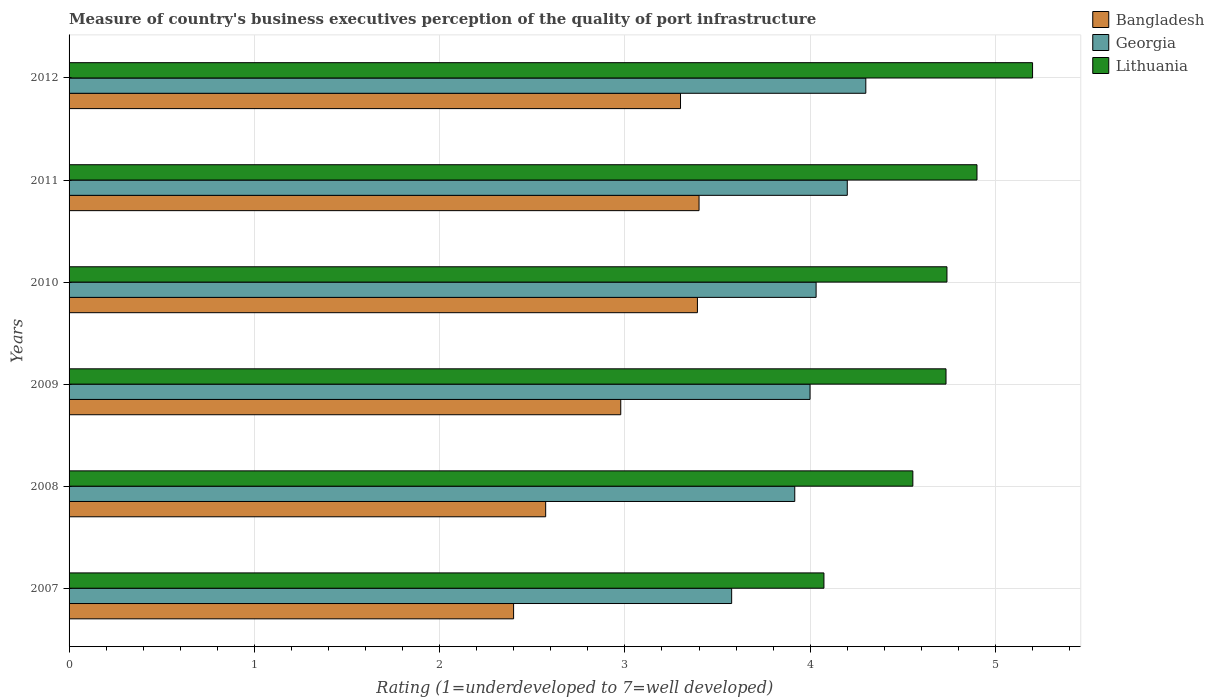How many different coloured bars are there?
Ensure brevity in your answer.  3. How many groups of bars are there?
Provide a succinct answer. 6. Are the number of bars per tick equal to the number of legend labels?
Provide a succinct answer. Yes. What is the label of the 1st group of bars from the top?
Offer a very short reply. 2012. In how many cases, is the number of bars for a given year not equal to the number of legend labels?
Offer a very short reply. 0. What is the ratings of the quality of port infrastructure in Lithuania in 2008?
Ensure brevity in your answer.  4.55. Across all years, what is the maximum ratings of the quality of port infrastructure in Lithuania?
Offer a terse response. 5.2. Across all years, what is the minimum ratings of the quality of port infrastructure in Lithuania?
Make the answer very short. 4.07. In which year was the ratings of the quality of port infrastructure in Georgia minimum?
Make the answer very short. 2007. What is the total ratings of the quality of port infrastructure in Bangladesh in the graph?
Offer a very short reply. 18.04. What is the difference between the ratings of the quality of port infrastructure in Georgia in 2008 and that in 2011?
Make the answer very short. -0.28. What is the difference between the ratings of the quality of port infrastructure in Bangladesh in 2007 and the ratings of the quality of port infrastructure in Georgia in 2012?
Your answer should be compact. -1.9. What is the average ratings of the quality of port infrastructure in Georgia per year?
Make the answer very short. 4. In the year 2008, what is the difference between the ratings of the quality of port infrastructure in Bangladesh and ratings of the quality of port infrastructure in Lithuania?
Ensure brevity in your answer.  -1.98. What is the ratio of the ratings of the quality of port infrastructure in Bangladesh in 2009 to that in 2012?
Ensure brevity in your answer.  0.9. Is the ratings of the quality of port infrastructure in Georgia in 2007 less than that in 2008?
Your response must be concise. Yes. What is the difference between the highest and the second highest ratings of the quality of port infrastructure in Georgia?
Give a very brief answer. 0.1. What is the difference between the highest and the lowest ratings of the quality of port infrastructure in Lithuania?
Ensure brevity in your answer.  1.13. Is the sum of the ratings of the quality of port infrastructure in Bangladesh in 2008 and 2011 greater than the maximum ratings of the quality of port infrastructure in Lithuania across all years?
Offer a very short reply. Yes. What does the 2nd bar from the top in 2009 represents?
Ensure brevity in your answer.  Georgia. What does the 3rd bar from the bottom in 2012 represents?
Ensure brevity in your answer.  Lithuania. How many bars are there?
Provide a short and direct response. 18. Are all the bars in the graph horizontal?
Your answer should be very brief. Yes. Are the values on the major ticks of X-axis written in scientific E-notation?
Your answer should be compact. No. Does the graph contain grids?
Ensure brevity in your answer.  Yes. Where does the legend appear in the graph?
Provide a short and direct response. Top right. How are the legend labels stacked?
Your answer should be very brief. Vertical. What is the title of the graph?
Your response must be concise. Measure of country's business executives perception of the quality of port infrastructure. What is the label or title of the X-axis?
Offer a very short reply. Rating (1=underdeveloped to 7=well developed). What is the Rating (1=underdeveloped to 7=well developed) of Bangladesh in 2007?
Offer a very short reply. 2.4. What is the Rating (1=underdeveloped to 7=well developed) in Georgia in 2007?
Provide a short and direct response. 3.58. What is the Rating (1=underdeveloped to 7=well developed) of Lithuania in 2007?
Your answer should be compact. 4.07. What is the Rating (1=underdeveloped to 7=well developed) of Bangladesh in 2008?
Provide a succinct answer. 2.57. What is the Rating (1=underdeveloped to 7=well developed) of Georgia in 2008?
Keep it short and to the point. 3.92. What is the Rating (1=underdeveloped to 7=well developed) of Lithuania in 2008?
Provide a short and direct response. 4.55. What is the Rating (1=underdeveloped to 7=well developed) of Bangladesh in 2009?
Keep it short and to the point. 2.98. What is the Rating (1=underdeveloped to 7=well developed) in Georgia in 2009?
Give a very brief answer. 4. What is the Rating (1=underdeveloped to 7=well developed) of Lithuania in 2009?
Ensure brevity in your answer.  4.73. What is the Rating (1=underdeveloped to 7=well developed) of Bangladesh in 2010?
Give a very brief answer. 3.39. What is the Rating (1=underdeveloped to 7=well developed) in Georgia in 2010?
Ensure brevity in your answer.  4.03. What is the Rating (1=underdeveloped to 7=well developed) of Lithuania in 2010?
Keep it short and to the point. 4.74. What is the Rating (1=underdeveloped to 7=well developed) in Georgia in 2012?
Offer a terse response. 4.3. What is the Rating (1=underdeveloped to 7=well developed) of Lithuania in 2012?
Your answer should be compact. 5.2. Across all years, what is the maximum Rating (1=underdeveloped to 7=well developed) of Bangladesh?
Offer a very short reply. 3.4. Across all years, what is the minimum Rating (1=underdeveloped to 7=well developed) in Bangladesh?
Give a very brief answer. 2.4. Across all years, what is the minimum Rating (1=underdeveloped to 7=well developed) in Georgia?
Keep it short and to the point. 3.58. Across all years, what is the minimum Rating (1=underdeveloped to 7=well developed) of Lithuania?
Your response must be concise. 4.07. What is the total Rating (1=underdeveloped to 7=well developed) in Bangladesh in the graph?
Offer a terse response. 18.04. What is the total Rating (1=underdeveloped to 7=well developed) of Georgia in the graph?
Ensure brevity in your answer.  24.02. What is the total Rating (1=underdeveloped to 7=well developed) in Lithuania in the graph?
Your answer should be very brief. 28.2. What is the difference between the Rating (1=underdeveloped to 7=well developed) in Bangladesh in 2007 and that in 2008?
Make the answer very short. -0.17. What is the difference between the Rating (1=underdeveloped to 7=well developed) of Georgia in 2007 and that in 2008?
Make the answer very short. -0.34. What is the difference between the Rating (1=underdeveloped to 7=well developed) of Lithuania in 2007 and that in 2008?
Your answer should be very brief. -0.48. What is the difference between the Rating (1=underdeveloped to 7=well developed) of Bangladesh in 2007 and that in 2009?
Provide a succinct answer. -0.58. What is the difference between the Rating (1=underdeveloped to 7=well developed) of Georgia in 2007 and that in 2009?
Provide a succinct answer. -0.42. What is the difference between the Rating (1=underdeveloped to 7=well developed) of Lithuania in 2007 and that in 2009?
Provide a succinct answer. -0.66. What is the difference between the Rating (1=underdeveloped to 7=well developed) in Bangladesh in 2007 and that in 2010?
Provide a succinct answer. -0.99. What is the difference between the Rating (1=underdeveloped to 7=well developed) in Georgia in 2007 and that in 2010?
Your answer should be very brief. -0.46. What is the difference between the Rating (1=underdeveloped to 7=well developed) in Lithuania in 2007 and that in 2010?
Provide a short and direct response. -0.66. What is the difference between the Rating (1=underdeveloped to 7=well developed) of Bangladesh in 2007 and that in 2011?
Provide a short and direct response. -1. What is the difference between the Rating (1=underdeveloped to 7=well developed) in Georgia in 2007 and that in 2011?
Your answer should be very brief. -0.62. What is the difference between the Rating (1=underdeveloped to 7=well developed) in Lithuania in 2007 and that in 2011?
Your answer should be compact. -0.83. What is the difference between the Rating (1=underdeveloped to 7=well developed) in Bangladesh in 2007 and that in 2012?
Your answer should be compact. -0.9. What is the difference between the Rating (1=underdeveloped to 7=well developed) in Georgia in 2007 and that in 2012?
Your answer should be compact. -0.72. What is the difference between the Rating (1=underdeveloped to 7=well developed) of Lithuania in 2007 and that in 2012?
Provide a short and direct response. -1.13. What is the difference between the Rating (1=underdeveloped to 7=well developed) in Bangladesh in 2008 and that in 2009?
Your response must be concise. -0.41. What is the difference between the Rating (1=underdeveloped to 7=well developed) of Georgia in 2008 and that in 2009?
Your response must be concise. -0.08. What is the difference between the Rating (1=underdeveloped to 7=well developed) of Lithuania in 2008 and that in 2009?
Make the answer very short. -0.18. What is the difference between the Rating (1=underdeveloped to 7=well developed) of Bangladesh in 2008 and that in 2010?
Provide a short and direct response. -0.82. What is the difference between the Rating (1=underdeveloped to 7=well developed) in Georgia in 2008 and that in 2010?
Offer a very short reply. -0.12. What is the difference between the Rating (1=underdeveloped to 7=well developed) in Lithuania in 2008 and that in 2010?
Your response must be concise. -0.18. What is the difference between the Rating (1=underdeveloped to 7=well developed) in Bangladesh in 2008 and that in 2011?
Keep it short and to the point. -0.83. What is the difference between the Rating (1=underdeveloped to 7=well developed) of Georgia in 2008 and that in 2011?
Your response must be concise. -0.28. What is the difference between the Rating (1=underdeveloped to 7=well developed) in Lithuania in 2008 and that in 2011?
Give a very brief answer. -0.35. What is the difference between the Rating (1=underdeveloped to 7=well developed) in Bangladesh in 2008 and that in 2012?
Ensure brevity in your answer.  -0.73. What is the difference between the Rating (1=underdeveloped to 7=well developed) in Georgia in 2008 and that in 2012?
Offer a terse response. -0.38. What is the difference between the Rating (1=underdeveloped to 7=well developed) of Lithuania in 2008 and that in 2012?
Offer a terse response. -0.65. What is the difference between the Rating (1=underdeveloped to 7=well developed) of Bangladesh in 2009 and that in 2010?
Provide a short and direct response. -0.41. What is the difference between the Rating (1=underdeveloped to 7=well developed) in Georgia in 2009 and that in 2010?
Your response must be concise. -0.03. What is the difference between the Rating (1=underdeveloped to 7=well developed) of Lithuania in 2009 and that in 2010?
Provide a succinct answer. -0.01. What is the difference between the Rating (1=underdeveloped to 7=well developed) in Bangladesh in 2009 and that in 2011?
Offer a terse response. -0.42. What is the difference between the Rating (1=underdeveloped to 7=well developed) of Georgia in 2009 and that in 2011?
Make the answer very short. -0.2. What is the difference between the Rating (1=underdeveloped to 7=well developed) of Lithuania in 2009 and that in 2011?
Your answer should be very brief. -0.17. What is the difference between the Rating (1=underdeveloped to 7=well developed) of Bangladesh in 2009 and that in 2012?
Your answer should be compact. -0.32. What is the difference between the Rating (1=underdeveloped to 7=well developed) of Georgia in 2009 and that in 2012?
Ensure brevity in your answer.  -0.3. What is the difference between the Rating (1=underdeveloped to 7=well developed) in Lithuania in 2009 and that in 2012?
Give a very brief answer. -0.47. What is the difference between the Rating (1=underdeveloped to 7=well developed) of Bangladesh in 2010 and that in 2011?
Your response must be concise. -0.01. What is the difference between the Rating (1=underdeveloped to 7=well developed) of Georgia in 2010 and that in 2011?
Keep it short and to the point. -0.17. What is the difference between the Rating (1=underdeveloped to 7=well developed) in Lithuania in 2010 and that in 2011?
Provide a short and direct response. -0.16. What is the difference between the Rating (1=underdeveloped to 7=well developed) in Bangladesh in 2010 and that in 2012?
Ensure brevity in your answer.  0.09. What is the difference between the Rating (1=underdeveloped to 7=well developed) of Georgia in 2010 and that in 2012?
Your response must be concise. -0.27. What is the difference between the Rating (1=underdeveloped to 7=well developed) in Lithuania in 2010 and that in 2012?
Make the answer very short. -0.46. What is the difference between the Rating (1=underdeveloped to 7=well developed) in Georgia in 2011 and that in 2012?
Provide a succinct answer. -0.1. What is the difference between the Rating (1=underdeveloped to 7=well developed) of Bangladesh in 2007 and the Rating (1=underdeveloped to 7=well developed) of Georgia in 2008?
Ensure brevity in your answer.  -1.52. What is the difference between the Rating (1=underdeveloped to 7=well developed) of Bangladesh in 2007 and the Rating (1=underdeveloped to 7=well developed) of Lithuania in 2008?
Provide a short and direct response. -2.15. What is the difference between the Rating (1=underdeveloped to 7=well developed) in Georgia in 2007 and the Rating (1=underdeveloped to 7=well developed) in Lithuania in 2008?
Your answer should be very brief. -0.98. What is the difference between the Rating (1=underdeveloped to 7=well developed) of Bangladesh in 2007 and the Rating (1=underdeveloped to 7=well developed) of Georgia in 2009?
Provide a short and direct response. -1.6. What is the difference between the Rating (1=underdeveloped to 7=well developed) in Bangladesh in 2007 and the Rating (1=underdeveloped to 7=well developed) in Lithuania in 2009?
Provide a short and direct response. -2.33. What is the difference between the Rating (1=underdeveloped to 7=well developed) of Georgia in 2007 and the Rating (1=underdeveloped to 7=well developed) of Lithuania in 2009?
Offer a very short reply. -1.16. What is the difference between the Rating (1=underdeveloped to 7=well developed) in Bangladesh in 2007 and the Rating (1=underdeveloped to 7=well developed) in Georgia in 2010?
Offer a very short reply. -1.63. What is the difference between the Rating (1=underdeveloped to 7=well developed) in Bangladesh in 2007 and the Rating (1=underdeveloped to 7=well developed) in Lithuania in 2010?
Offer a very short reply. -2.34. What is the difference between the Rating (1=underdeveloped to 7=well developed) of Georgia in 2007 and the Rating (1=underdeveloped to 7=well developed) of Lithuania in 2010?
Provide a short and direct response. -1.16. What is the difference between the Rating (1=underdeveloped to 7=well developed) of Bangladesh in 2007 and the Rating (1=underdeveloped to 7=well developed) of Georgia in 2011?
Your answer should be very brief. -1.8. What is the difference between the Rating (1=underdeveloped to 7=well developed) in Bangladesh in 2007 and the Rating (1=underdeveloped to 7=well developed) in Lithuania in 2011?
Offer a terse response. -2.5. What is the difference between the Rating (1=underdeveloped to 7=well developed) of Georgia in 2007 and the Rating (1=underdeveloped to 7=well developed) of Lithuania in 2011?
Ensure brevity in your answer.  -1.32. What is the difference between the Rating (1=underdeveloped to 7=well developed) of Bangladesh in 2007 and the Rating (1=underdeveloped to 7=well developed) of Georgia in 2012?
Provide a short and direct response. -1.9. What is the difference between the Rating (1=underdeveloped to 7=well developed) in Bangladesh in 2007 and the Rating (1=underdeveloped to 7=well developed) in Lithuania in 2012?
Ensure brevity in your answer.  -2.8. What is the difference between the Rating (1=underdeveloped to 7=well developed) of Georgia in 2007 and the Rating (1=underdeveloped to 7=well developed) of Lithuania in 2012?
Your response must be concise. -1.62. What is the difference between the Rating (1=underdeveloped to 7=well developed) of Bangladesh in 2008 and the Rating (1=underdeveloped to 7=well developed) of Georgia in 2009?
Offer a terse response. -1.43. What is the difference between the Rating (1=underdeveloped to 7=well developed) of Bangladesh in 2008 and the Rating (1=underdeveloped to 7=well developed) of Lithuania in 2009?
Provide a succinct answer. -2.16. What is the difference between the Rating (1=underdeveloped to 7=well developed) in Georgia in 2008 and the Rating (1=underdeveloped to 7=well developed) in Lithuania in 2009?
Provide a short and direct response. -0.82. What is the difference between the Rating (1=underdeveloped to 7=well developed) of Bangladesh in 2008 and the Rating (1=underdeveloped to 7=well developed) of Georgia in 2010?
Provide a succinct answer. -1.46. What is the difference between the Rating (1=underdeveloped to 7=well developed) of Bangladesh in 2008 and the Rating (1=underdeveloped to 7=well developed) of Lithuania in 2010?
Your answer should be compact. -2.17. What is the difference between the Rating (1=underdeveloped to 7=well developed) in Georgia in 2008 and the Rating (1=underdeveloped to 7=well developed) in Lithuania in 2010?
Provide a short and direct response. -0.82. What is the difference between the Rating (1=underdeveloped to 7=well developed) of Bangladesh in 2008 and the Rating (1=underdeveloped to 7=well developed) of Georgia in 2011?
Your answer should be compact. -1.63. What is the difference between the Rating (1=underdeveloped to 7=well developed) in Bangladesh in 2008 and the Rating (1=underdeveloped to 7=well developed) in Lithuania in 2011?
Your response must be concise. -2.33. What is the difference between the Rating (1=underdeveloped to 7=well developed) of Georgia in 2008 and the Rating (1=underdeveloped to 7=well developed) of Lithuania in 2011?
Your answer should be compact. -0.98. What is the difference between the Rating (1=underdeveloped to 7=well developed) of Bangladesh in 2008 and the Rating (1=underdeveloped to 7=well developed) of Georgia in 2012?
Your answer should be compact. -1.73. What is the difference between the Rating (1=underdeveloped to 7=well developed) of Bangladesh in 2008 and the Rating (1=underdeveloped to 7=well developed) of Lithuania in 2012?
Make the answer very short. -2.63. What is the difference between the Rating (1=underdeveloped to 7=well developed) in Georgia in 2008 and the Rating (1=underdeveloped to 7=well developed) in Lithuania in 2012?
Provide a short and direct response. -1.28. What is the difference between the Rating (1=underdeveloped to 7=well developed) of Bangladesh in 2009 and the Rating (1=underdeveloped to 7=well developed) of Georgia in 2010?
Your answer should be compact. -1.05. What is the difference between the Rating (1=underdeveloped to 7=well developed) in Bangladesh in 2009 and the Rating (1=underdeveloped to 7=well developed) in Lithuania in 2010?
Offer a terse response. -1.76. What is the difference between the Rating (1=underdeveloped to 7=well developed) in Georgia in 2009 and the Rating (1=underdeveloped to 7=well developed) in Lithuania in 2010?
Provide a succinct answer. -0.74. What is the difference between the Rating (1=underdeveloped to 7=well developed) of Bangladesh in 2009 and the Rating (1=underdeveloped to 7=well developed) of Georgia in 2011?
Provide a succinct answer. -1.22. What is the difference between the Rating (1=underdeveloped to 7=well developed) of Bangladesh in 2009 and the Rating (1=underdeveloped to 7=well developed) of Lithuania in 2011?
Make the answer very short. -1.92. What is the difference between the Rating (1=underdeveloped to 7=well developed) of Georgia in 2009 and the Rating (1=underdeveloped to 7=well developed) of Lithuania in 2011?
Your answer should be compact. -0.9. What is the difference between the Rating (1=underdeveloped to 7=well developed) in Bangladesh in 2009 and the Rating (1=underdeveloped to 7=well developed) in Georgia in 2012?
Your response must be concise. -1.32. What is the difference between the Rating (1=underdeveloped to 7=well developed) of Bangladesh in 2009 and the Rating (1=underdeveloped to 7=well developed) of Lithuania in 2012?
Provide a succinct answer. -2.22. What is the difference between the Rating (1=underdeveloped to 7=well developed) in Georgia in 2009 and the Rating (1=underdeveloped to 7=well developed) in Lithuania in 2012?
Keep it short and to the point. -1.2. What is the difference between the Rating (1=underdeveloped to 7=well developed) of Bangladesh in 2010 and the Rating (1=underdeveloped to 7=well developed) of Georgia in 2011?
Offer a terse response. -0.81. What is the difference between the Rating (1=underdeveloped to 7=well developed) in Bangladesh in 2010 and the Rating (1=underdeveloped to 7=well developed) in Lithuania in 2011?
Ensure brevity in your answer.  -1.51. What is the difference between the Rating (1=underdeveloped to 7=well developed) in Georgia in 2010 and the Rating (1=underdeveloped to 7=well developed) in Lithuania in 2011?
Your answer should be compact. -0.87. What is the difference between the Rating (1=underdeveloped to 7=well developed) in Bangladesh in 2010 and the Rating (1=underdeveloped to 7=well developed) in Georgia in 2012?
Give a very brief answer. -0.91. What is the difference between the Rating (1=underdeveloped to 7=well developed) in Bangladesh in 2010 and the Rating (1=underdeveloped to 7=well developed) in Lithuania in 2012?
Offer a terse response. -1.81. What is the difference between the Rating (1=underdeveloped to 7=well developed) in Georgia in 2010 and the Rating (1=underdeveloped to 7=well developed) in Lithuania in 2012?
Provide a succinct answer. -1.17. What is the difference between the Rating (1=underdeveloped to 7=well developed) in Bangladesh in 2011 and the Rating (1=underdeveloped to 7=well developed) in Georgia in 2012?
Your answer should be very brief. -0.9. What is the average Rating (1=underdeveloped to 7=well developed) of Bangladesh per year?
Provide a short and direct response. 3.01. What is the average Rating (1=underdeveloped to 7=well developed) in Georgia per year?
Your answer should be very brief. 4. What is the average Rating (1=underdeveloped to 7=well developed) in Lithuania per year?
Your answer should be compact. 4.7. In the year 2007, what is the difference between the Rating (1=underdeveloped to 7=well developed) of Bangladesh and Rating (1=underdeveloped to 7=well developed) of Georgia?
Your answer should be very brief. -1.18. In the year 2007, what is the difference between the Rating (1=underdeveloped to 7=well developed) of Bangladesh and Rating (1=underdeveloped to 7=well developed) of Lithuania?
Provide a short and direct response. -1.67. In the year 2007, what is the difference between the Rating (1=underdeveloped to 7=well developed) of Georgia and Rating (1=underdeveloped to 7=well developed) of Lithuania?
Offer a very short reply. -0.5. In the year 2008, what is the difference between the Rating (1=underdeveloped to 7=well developed) of Bangladesh and Rating (1=underdeveloped to 7=well developed) of Georgia?
Provide a succinct answer. -1.34. In the year 2008, what is the difference between the Rating (1=underdeveloped to 7=well developed) in Bangladesh and Rating (1=underdeveloped to 7=well developed) in Lithuania?
Your answer should be very brief. -1.98. In the year 2008, what is the difference between the Rating (1=underdeveloped to 7=well developed) in Georgia and Rating (1=underdeveloped to 7=well developed) in Lithuania?
Give a very brief answer. -0.64. In the year 2009, what is the difference between the Rating (1=underdeveloped to 7=well developed) of Bangladesh and Rating (1=underdeveloped to 7=well developed) of Georgia?
Offer a terse response. -1.02. In the year 2009, what is the difference between the Rating (1=underdeveloped to 7=well developed) in Bangladesh and Rating (1=underdeveloped to 7=well developed) in Lithuania?
Offer a very short reply. -1.76. In the year 2009, what is the difference between the Rating (1=underdeveloped to 7=well developed) in Georgia and Rating (1=underdeveloped to 7=well developed) in Lithuania?
Make the answer very short. -0.73. In the year 2010, what is the difference between the Rating (1=underdeveloped to 7=well developed) in Bangladesh and Rating (1=underdeveloped to 7=well developed) in Georgia?
Keep it short and to the point. -0.64. In the year 2010, what is the difference between the Rating (1=underdeveloped to 7=well developed) in Bangladesh and Rating (1=underdeveloped to 7=well developed) in Lithuania?
Keep it short and to the point. -1.35. In the year 2010, what is the difference between the Rating (1=underdeveloped to 7=well developed) of Georgia and Rating (1=underdeveloped to 7=well developed) of Lithuania?
Keep it short and to the point. -0.71. In the year 2011, what is the difference between the Rating (1=underdeveloped to 7=well developed) of Bangladesh and Rating (1=underdeveloped to 7=well developed) of Georgia?
Ensure brevity in your answer.  -0.8. In the year 2011, what is the difference between the Rating (1=underdeveloped to 7=well developed) in Georgia and Rating (1=underdeveloped to 7=well developed) in Lithuania?
Provide a short and direct response. -0.7. In the year 2012, what is the difference between the Rating (1=underdeveloped to 7=well developed) in Bangladesh and Rating (1=underdeveloped to 7=well developed) in Georgia?
Ensure brevity in your answer.  -1. In the year 2012, what is the difference between the Rating (1=underdeveloped to 7=well developed) of Bangladesh and Rating (1=underdeveloped to 7=well developed) of Lithuania?
Your answer should be compact. -1.9. What is the ratio of the Rating (1=underdeveloped to 7=well developed) of Bangladesh in 2007 to that in 2008?
Offer a terse response. 0.93. What is the ratio of the Rating (1=underdeveloped to 7=well developed) of Georgia in 2007 to that in 2008?
Your response must be concise. 0.91. What is the ratio of the Rating (1=underdeveloped to 7=well developed) of Lithuania in 2007 to that in 2008?
Provide a succinct answer. 0.89. What is the ratio of the Rating (1=underdeveloped to 7=well developed) in Bangladesh in 2007 to that in 2009?
Give a very brief answer. 0.81. What is the ratio of the Rating (1=underdeveloped to 7=well developed) in Georgia in 2007 to that in 2009?
Keep it short and to the point. 0.89. What is the ratio of the Rating (1=underdeveloped to 7=well developed) of Lithuania in 2007 to that in 2009?
Your answer should be compact. 0.86. What is the ratio of the Rating (1=underdeveloped to 7=well developed) of Bangladesh in 2007 to that in 2010?
Give a very brief answer. 0.71. What is the ratio of the Rating (1=underdeveloped to 7=well developed) in Georgia in 2007 to that in 2010?
Offer a very short reply. 0.89. What is the ratio of the Rating (1=underdeveloped to 7=well developed) in Lithuania in 2007 to that in 2010?
Keep it short and to the point. 0.86. What is the ratio of the Rating (1=underdeveloped to 7=well developed) in Bangladesh in 2007 to that in 2011?
Provide a succinct answer. 0.71. What is the ratio of the Rating (1=underdeveloped to 7=well developed) of Georgia in 2007 to that in 2011?
Ensure brevity in your answer.  0.85. What is the ratio of the Rating (1=underdeveloped to 7=well developed) in Lithuania in 2007 to that in 2011?
Your answer should be compact. 0.83. What is the ratio of the Rating (1=underdeveloped to 7=well developed) of Bangladesh in 2007 to that in 2012?
Make the answer very short. 0.73. What is the ratio of the Rating (1=underdeveloped to 7=well developed) in Georgia in 2007 to that in 2012?
Keep it short and to the point. 0.83. What is the ratio of the Rating (1=underdeveloped to 7=well developed) in Lithuania in 2007 to that in 2012?
Provide a short and direct response. 0.78. What is the ratio of the Rating (1=underdeveloped to 7=well developed) in Bangladesh in 2008 to that in 2009?
Your answer should be compact. 0.86. What is the ratio of the Rating (1=underdeveloped to 7=well developed) of Georgia in 2008 to that in 2009?
Offer a very short reply. 0.98. What is the ratio of the Rating (1=underdeveloped to 7=well developed) in Lithuania in 2008 to that in 2009?
Provide a succinct answer. 0.96. What is the ratio of the Rating (1=underdeveloped to 7=well developed) in Bangladesh in 2008 to that in 2010?
Keep it short and to the point. 0.76. What is the ratio of the Rating (1=underdeveloped to 7=well developed) of Georgia in 2008 to that in 2010?
Offer a terse response. 0.97. What is the ratio of the Rating (1=underdeveloped to 7=well developed) of Lithuania in 2008 to that in 2010?
Your response must be concise. 0.96. What is the ratio of the Rating (1=underdeveloped to 7=well developed) of Bangladesh in 2008 to that in 2011?
Offer a very short reply. 0.76. What is the ratio of the Rating (1=underdeveloped to 7=well developed) in Georgia in 2008 to that in 2011?
Your response must be concise. 0.93. What is the ratio of the Rating (1=underdeveloped to 7=well developed) of Lithuania in 2008 to that in 2011?
Your response must be concise. 0.93. What is the ratio of the Rating (1=underdeveloped to 7=well developed) in Bangladesh in 2008 to that in 2012?
Your response must be concise. 0.78. What is the ratio of the Rating (1=underdeveloped to 7=well developed) in Georgia in 2008 to that in 2012?
Ensure brevity in your answer.  0.91. What is the ratio of the Rating (1=underdeveloped to 7=well developed) of Lithuania in 2008 to that in 2012?
Ensure brevity in your answer.  0.88. What is the ratio of the Rating (1=underdeveloped to 7=well developed) in Bangladesh in 2009 to that in 2010?
Your answer should be very brief. 0.88. What is the ratio of the Rating (1=underdeveloped to 7=well developed) of Georgia in 2009 to that in 2010?
Make the answer very short. 0.99. What is the ratio of the Rating (1=underdeveloped to 7=well developed) of Lithuania in 2009 to that in 2010?
Your answer should be very brief. 1. What is the ratio of the Rating (1=underdeveloped to 7=well developed) of Bangladesh in 2009 to that in 2011?
Ensure brevity in your answer.  0.88. What is the ratio of the Rating (1=underdeveloped to 7=well developed) of Georgia in 2009 to that in 2011?
Give a very brief answer. 0.95. What is the ratio of the Rating (1=underdeveloped to 7=well developed) in Lithuania in 2009 to that in 2011?
Give a very brief answer. 0.97. What is the ratio of the Rating (1=underdeveloped to 7=well developed) in Bangladesh in 2009 to that in 2012?
Provide a succinct answer. 0.9. What is the ratio of the Rating (1=underdeveloped to 7=well developed) of Georgia in 2009 to that in 2012?
Make the answer very short. 0.93. What is the ratio of the Rating (1=underdeveloped to 7=well developed) of Lithuania in 2009 to that in 2012?
Ensure brevity in your answer.  0.91. What is the ratio of the Rating (1=underdeveloped to 7=well developed) of Bangladesh in 2010 to that in 2011?
Give a very brief answer. 1. What is the ratio of the Rating (1=underdeveloped to 7=well developed) in Georgia in 2010 to that in 2011?
Offer a terse response. 0.96. What is the ratio of the Rating (1=underdeveloped to 7=well developed) in Lithuania in 2010 to that in 2011?
Make the answer very short. 0.97. What is the ratio of the Rating (1=underdeveloped to 7=well developed) of Bangladesh in 2010 to that in 2012?
Your answer should be compact. 1.03. What is the ratio of the Rating (1=underdeveloped to 7=well developed) in Georgia in 2010 to that in 2012?
Your response must be concise. 0.94. What is the ratio of the Rating (1=underdeveloped to 7=well developed) of Lithuania in 2010 to that in 2012?
Provide a short and direct response. 0.91. What is the ratio of the Rating (1=underdeveloped to 7=well developed) in Bangladesh in 2011 to that in 2012?
Your answer should be very brief. 1.03. What is the ratio of the Rating (1=underdeveloped to 7=well developed) of Georgia in 2011 to that in 2012?
Your response must be concise. 0.98. What is the ratio of the Rating (1=underdeveloped to 7=well developed) of Lithuania in 2011 to that in 2012?
Your answer should be very brief. 0.94. What is the difference between the highest and the second highest Rating (1=underdeveloped to 7=well developed) of Bangladesh?
Ensure brevity in your answer.  0.01. What is the difference between the highest and the second highest Rating (1=underdeveloped to 7=well developed) in Lithuania?
Offer a terse response. 0.3. What is the difference between the highest and the lowest Rating (1=underdeveloped to 7=well developed) of Georgia?
Offer a very short reply. 0.72. What is the difference between the highest and the lowest Rating (1=underdeveloped to 7=well developed) in Lithuania?
Ensure brevity in your answer.  1.13. 